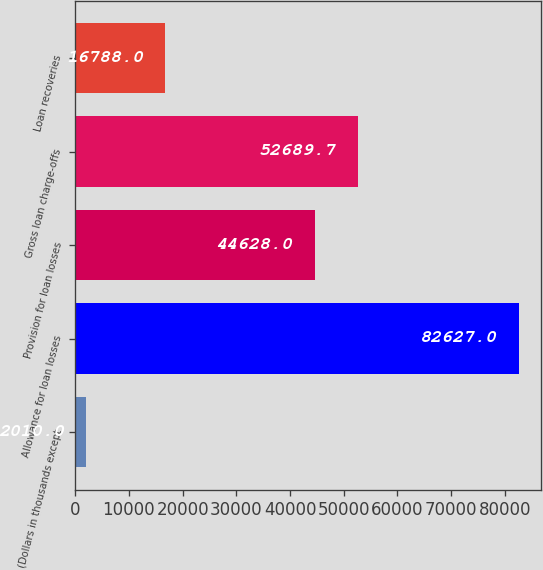Convert chart to OTSL. <chart><loc_0><loc_0><loc_500><loc_500><bar_chart><fcel>(Dollars in thousands except<fcel>Allowance for loan losses<fcel>Provision for loan losses<fcel>Gross loan charge-offs<fcel>Loan recoveries<nl><fcel>2010<fcel>82627<fcel>44628<fcel>52689.7<fcel>16788<nl></chart> 